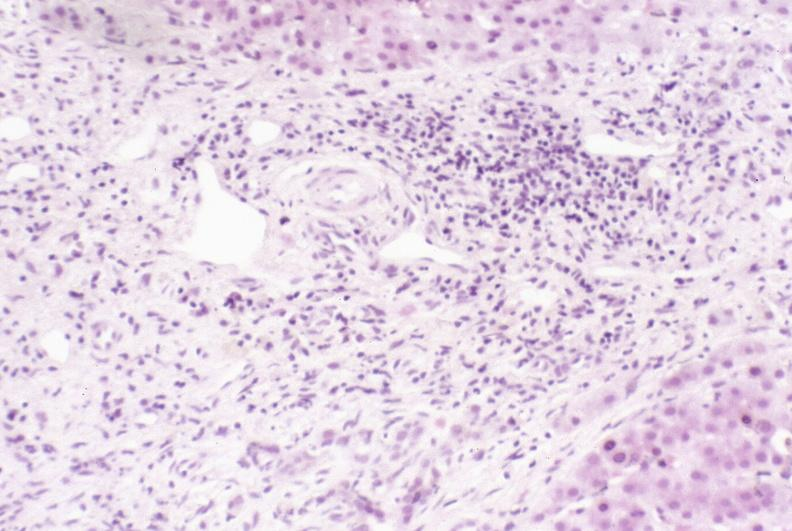what is present?
Answer the question using a single word or phrase. Liver 